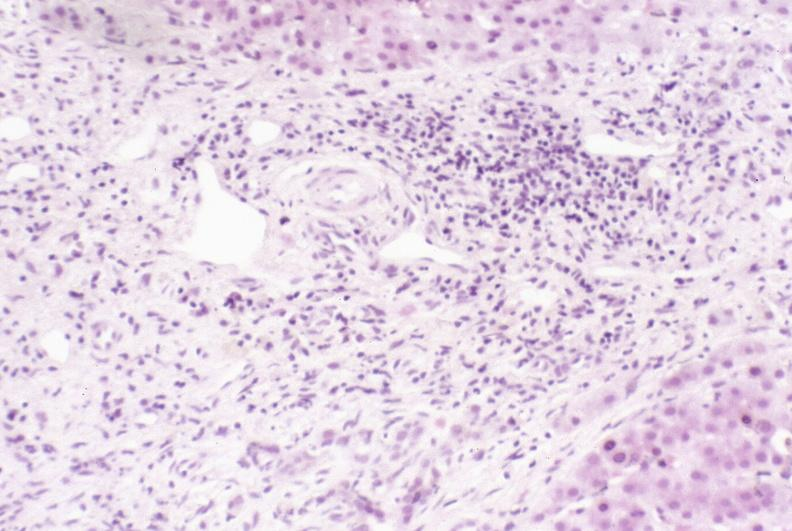what is present?
Answer the question using a single word or phrase. Liver 